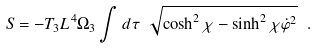Convert formula to latex. <formula><loc_0><loc_0><loc_500><loc_500>S = - T _ { 3 } L ^ { 4 } \Omega _ { 3 } \int d \tau \ \sqrt { \cosh ^ { 2 } \chi - \sinh ^ { 2 } \chi \dot { \varphi } ^ { 2 } } \ .</formula> 